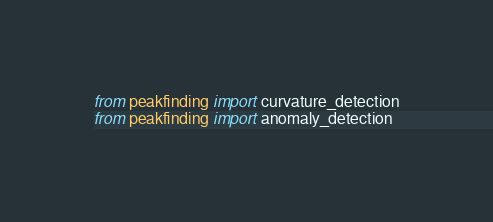Convert code to text. <code><loc_0><loc_0><loc_500><loc_500><_Python_>from peakfinding import curvature_detection
from peakfinding import anomaly_detection
</code> 